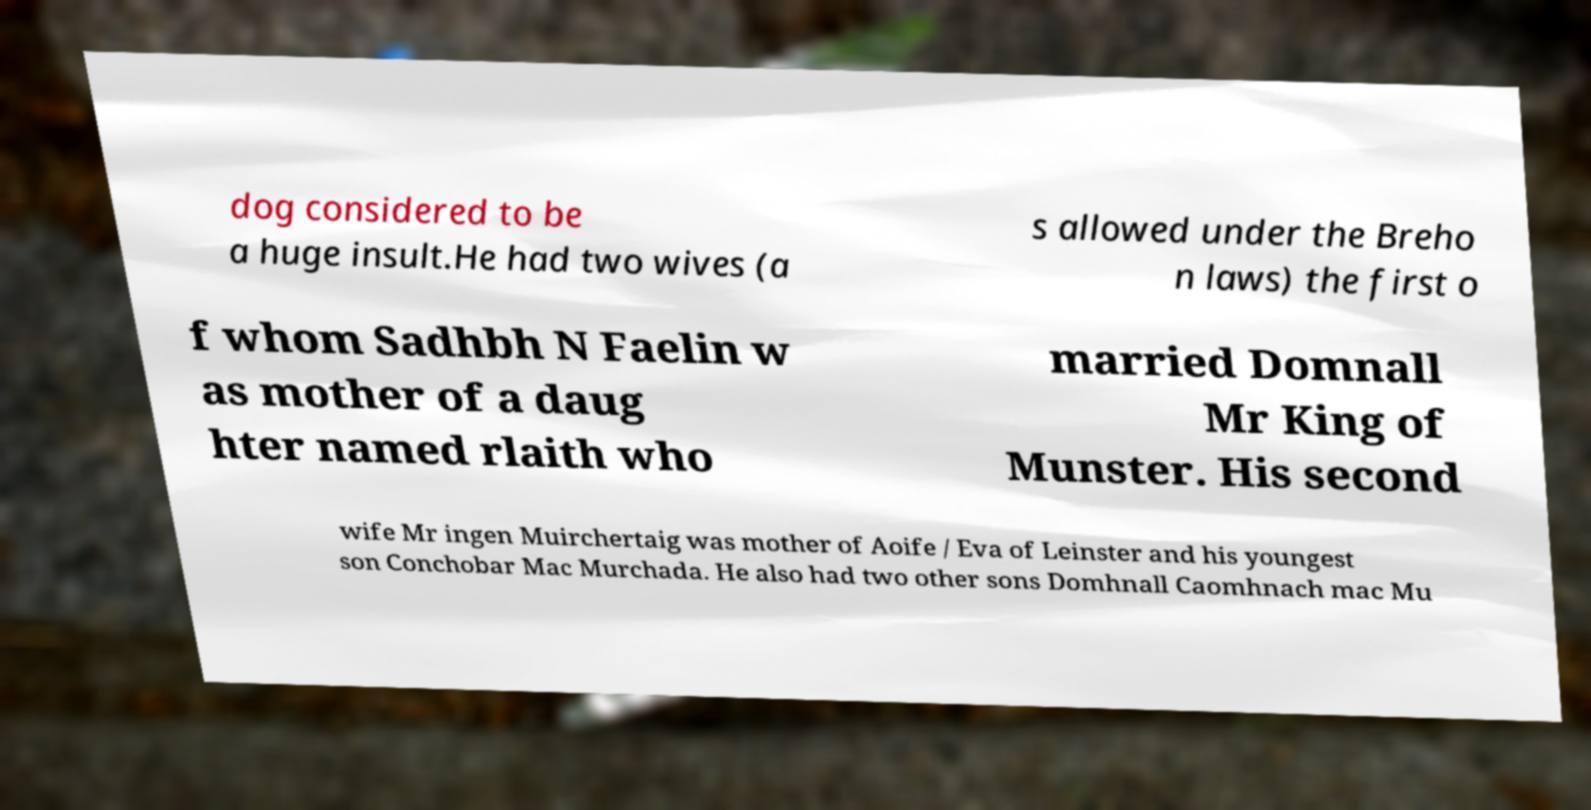Can you read and provide the text displayed in the image?This photo seems to have some interesting text. Can you extract and type it out for me? dog considered to be a huge insult.He had two wives (a s allowed under the Breho n laws) the first o f whom Sadhbh N Faelin w as mother of a daug hter named rlaith who married Domnall Mr King of Munster. His second wife Mr ingen Muirchertaig was mother of Aoife / Eva of Leinster and his youngest son Conchobar Mac Murchada. He also had two other sons Domhnall Caomhnach mac Mu 